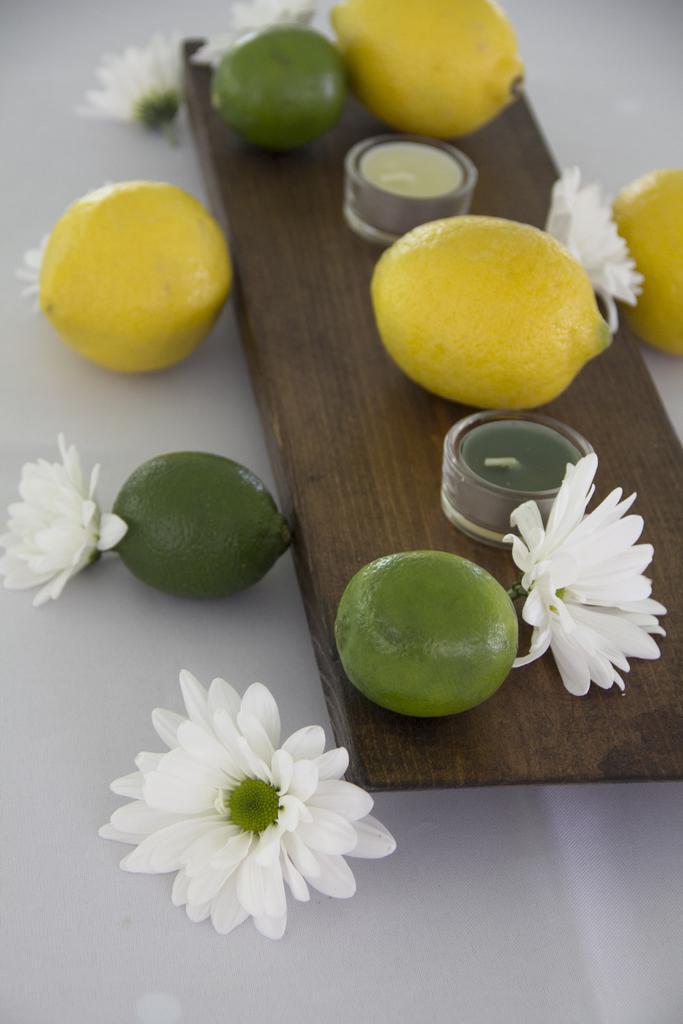Please provide a concise description of this image. In this picture we can see some fruits, flowers and other objects on the wooden board. There are fruits and flowers on a white surface. 